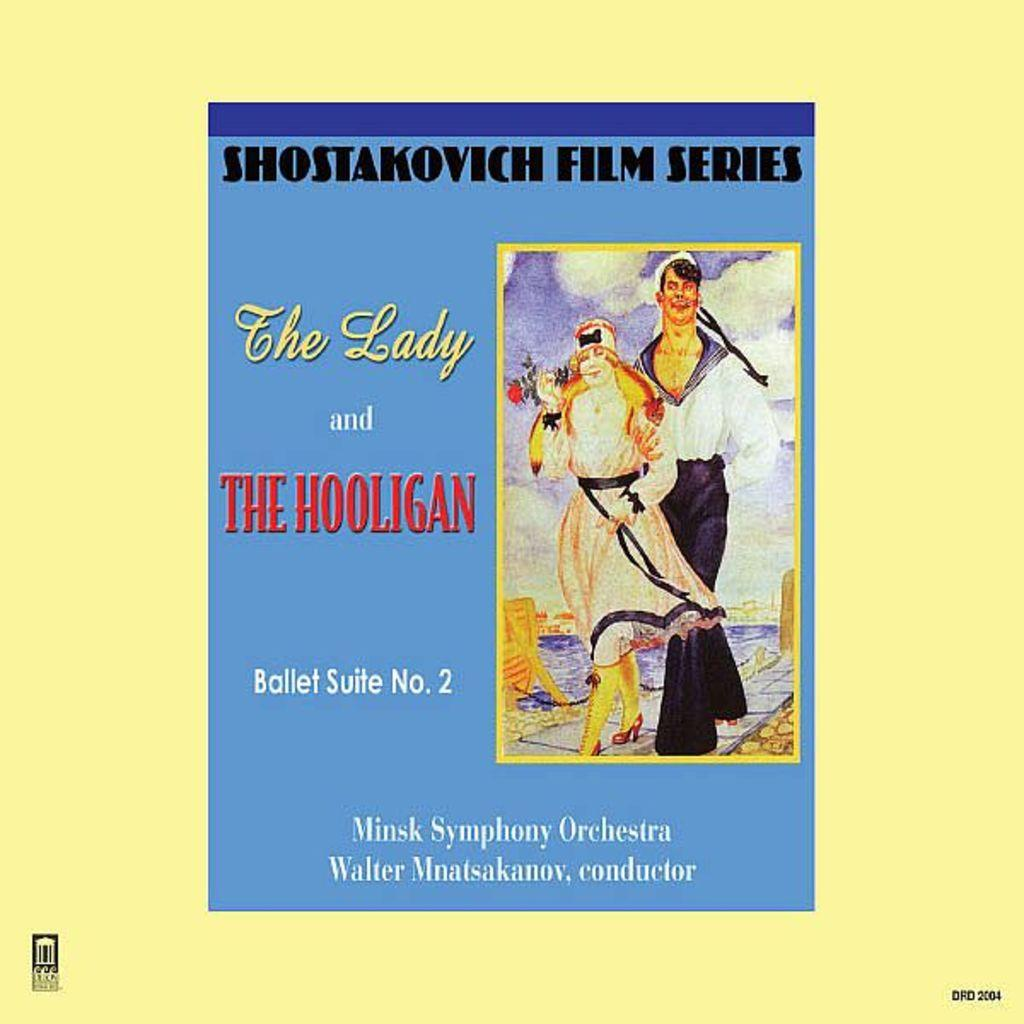What is present in the image that contains a picture and text? There is a poster in the image that contains a picture and text. Can you describe the picture on the poster? The provided facts do not give information about the picture on the poster, so we cannot describe it. What type of information is conveyed through the text on the poster? The provided facts do not give information about the text on the poster, so we cannot describe the information conveyed. What song is being played by the train in the image? There is no train or song present in the image; it only contains a poster with a picture and text. 